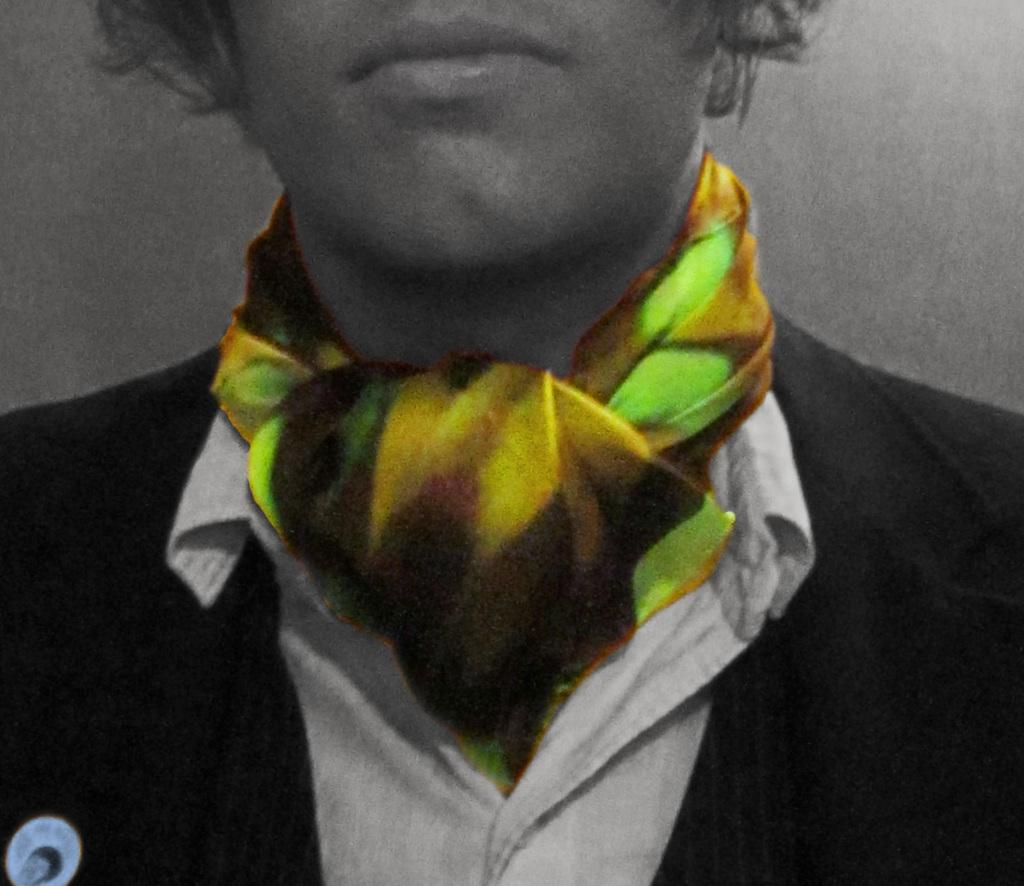Who is present in the image? There is a man in the image. What is the man wearing on his upper body? The man is wearing a white shirt and a black suit. What accessory is the man wearing around his neck? The man is wearing a colorful muffler. What time of day is the man observing his parent in the image? There is no indication of time of day or any parent in the image; it only shows a man wearing a white shirt, black suit, and colorful muffler. 